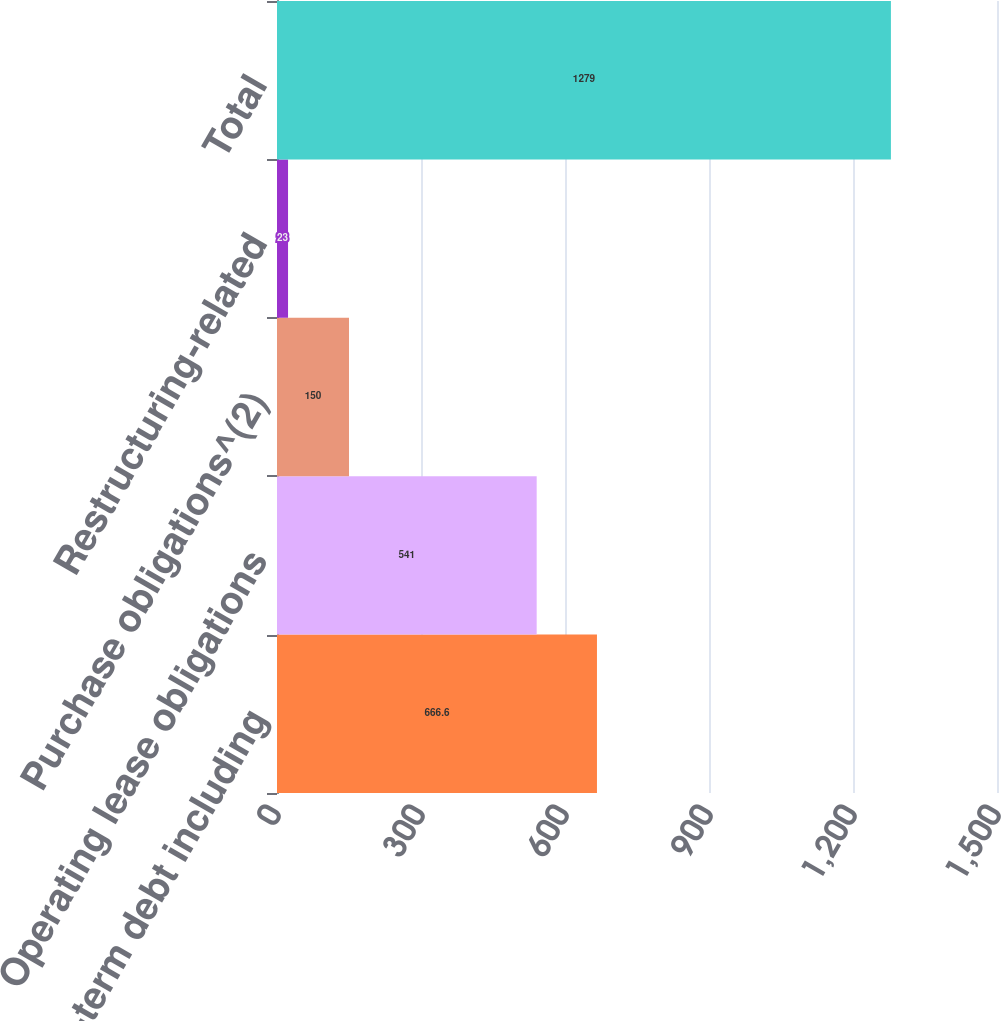Convert chart. <chart><loc_0><loc_0><loc_500><loc_500><bar_chart><fcel>Long-term debt including<fcel>Operating lease obligations<fcel>Purchase obligations^(2)<fcel>Restructuring-related<fcel>Total<nl><fcel>666.6<fcel>541<fcel>150<fcel>23<fcel>1279<nl></chart> 